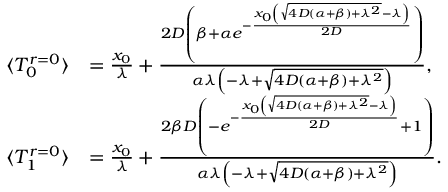<formula> <loc_0><loc_0><loc_500><loc_500>\begin{array} { r l } { \langle T _ { 0 } ^ { r = 0 } \rangle } & { = \frac { x _ { 0 } } { \lambda } + \frac { 2 D \left ( \beta + \alpha e ^ { - \frac { x _ { 0 } \left ( \sqrt { 4 D ( \alpha + \beta ) + \lambda ^ { 2 } } - \lambda \right ) } { 2 D } } \right ) } { \alpha \lambda \left ( - \lambda + \sqrt { 4 D ( \alpha + \beta ) + \lambda ^ { 2 } } \right ) } , } \\ { \langle T _ { 1 } ^ { r = 0 } \rangle } & { = \frac { x _ { 0 } } { \lambda } + \frac { 2 \beta D \left ( - e ^ { - \frac { x _ { 0 } \left ( \sqrt { 4 D ( \alpha + \beta ) + \lambda ^ { 2 } } - \lambda \right ) } { 2 D } } + 1 \right ) } { \alpha \lambda \left ( - \lambda + \sqrt { 4 D ( \alpha + \beta ) + \lambda ^ { 2 } } \right ) } . } \end{array}</formula> 